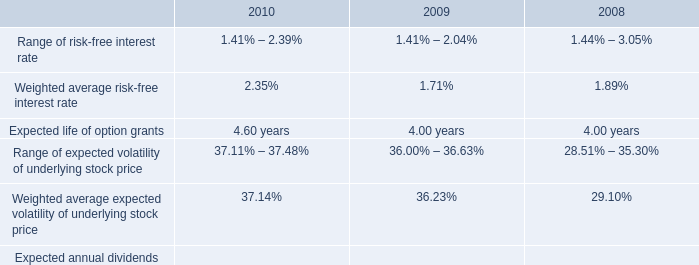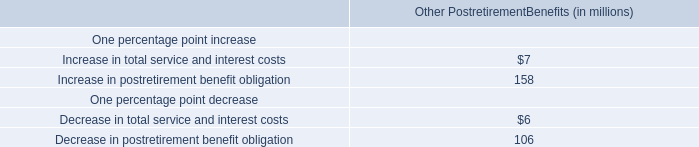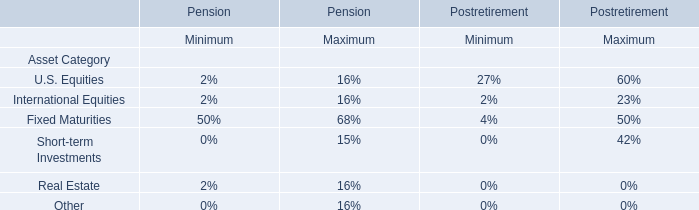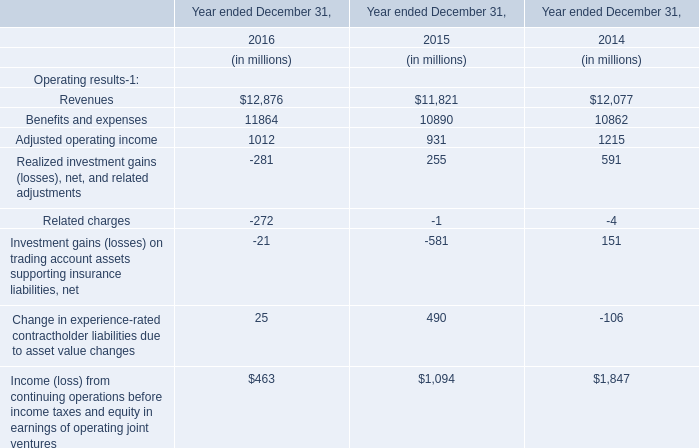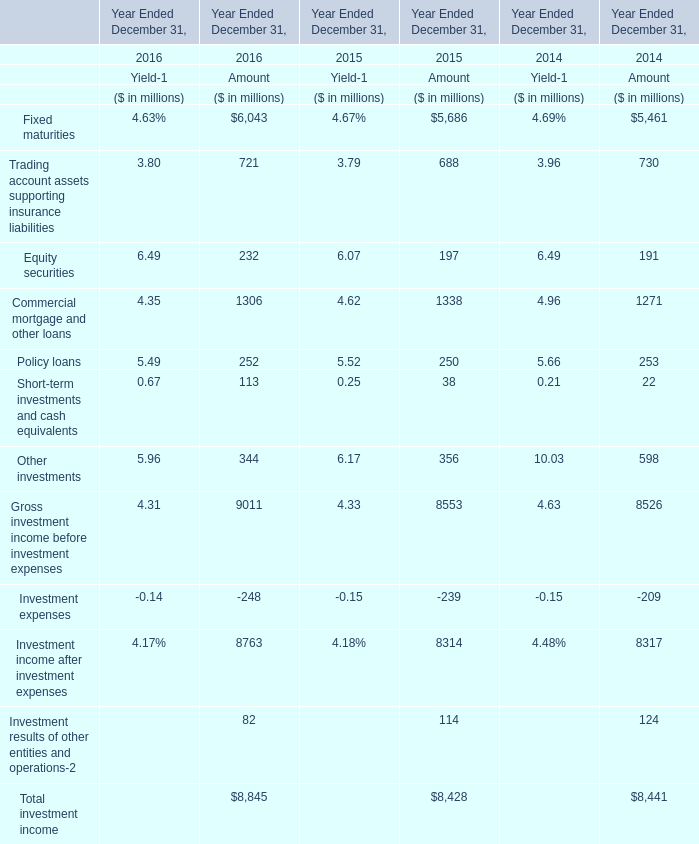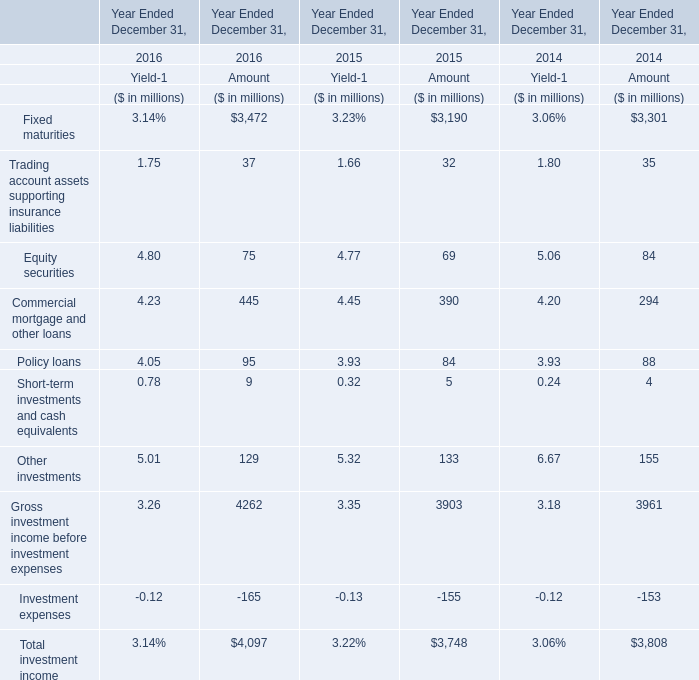What will Policy loans for amount be like in 2017 if it develops with the same increasing rate as current? (in million) 
Computations: ((((95 - 84) / 84) + 1) * 95)
Answer: 107.44048. 